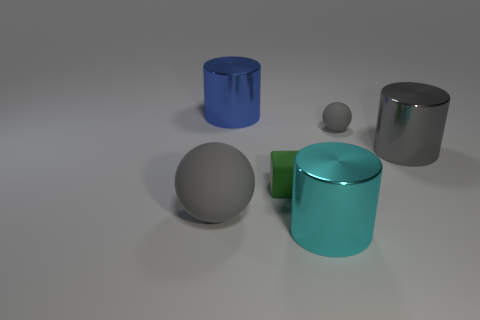Add 3 yellow shiny blocks. How many objects exist? 9 Subtract all spheres. How many objects are left? 4 Add 2 metal cylinders. How many metal cylinders are left? 5 Add 1 green things. How many green things exist? 2 Subtract 0 purple spheres. How many objects are left? 6 Subtract all tiny gray matte cubes. Subtract all tiny balls. How many objects are left? 5 